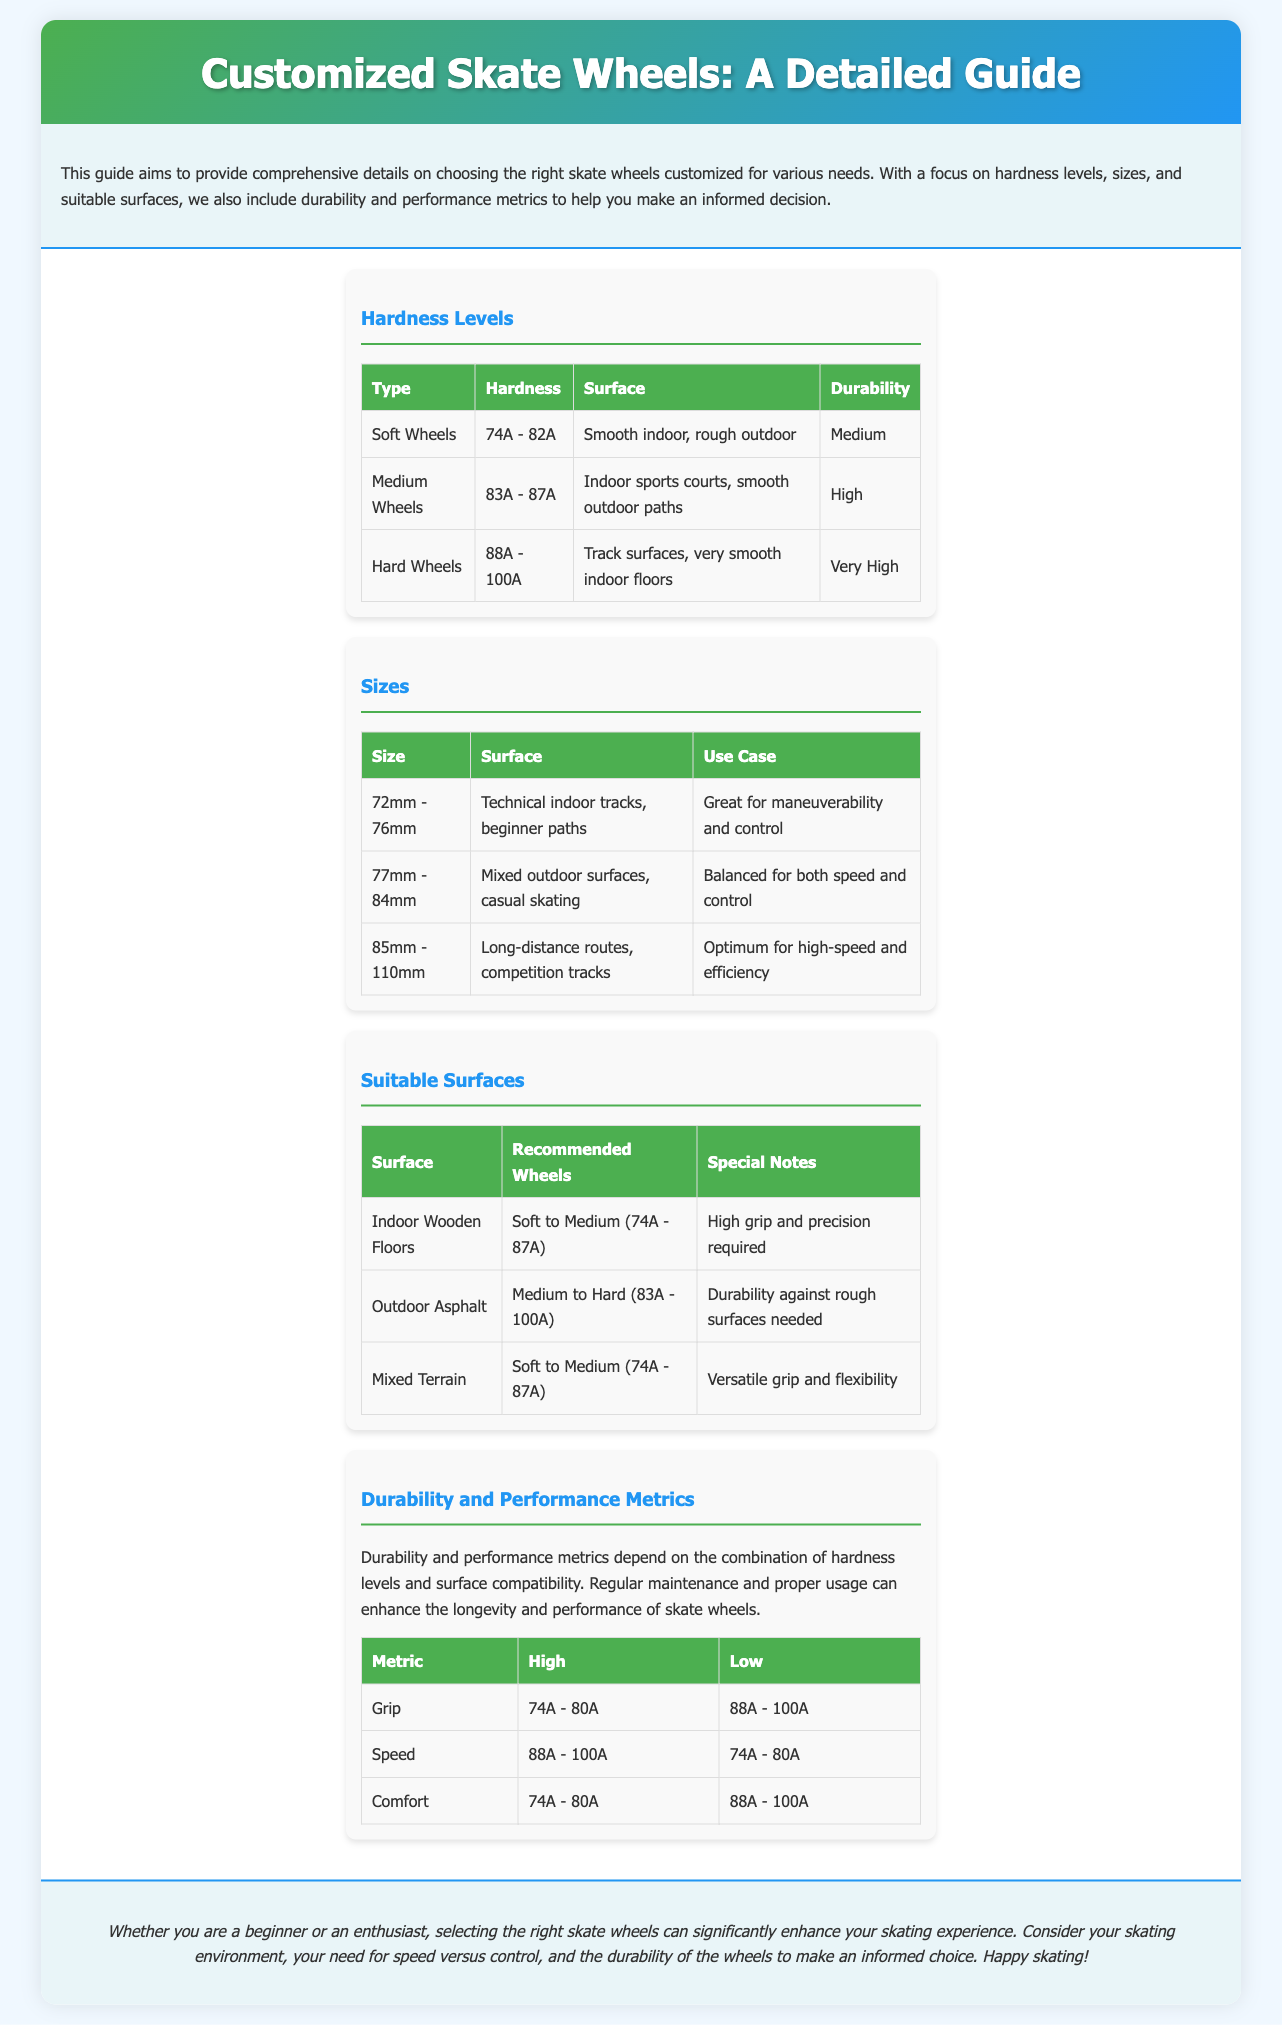what is the hardness range for soft wheels? The document states that the hardness for soft wheels ranges from 74A to 82A.
Answer: 74A - 82A what surfaces are medium wheels suitable for? According to the document, medium wheels are suitable for indoor sports courts and smooth outdoor paths.
Answer: Indoor sports courts, smooth outdoor paths what is the size range for high-speed wheels? The document indicates that the size range for high-speed wheels is 85mm to 110mm.
Answer: 85mm - 110mm which wheels are recommended for indoor wooden floors? The document recommends soft to medium wheels for indoor wooden floors.
Answer: Soft to Medium (74A - 87A) what is the grip metric range for high performance? The document mentions that the grip metric for high performance is 74A - 80A.
Answer: 74A - 80A why might an amateur skater choose soft wheels? Soft wheels provide better grip and comfort, making them suitable for beginners.
Answer: Better grip and comfort what special notes are provided for outdoor asphalt surfaces? The document notes that durability against rough surfaces is needed for outdoor asphalt.
Answer: Durability against rough surfaces needed what type of wheels should be used on mixed terrain? The document suggests using soft to medium wheels on mixed terrain.
Answer: Soft to Medium (74A - 87A) which hardness range is ideal for speed? The document highlights that a hardness range of 88A - 100A is ideal for speed.
Answer: 88A - 100A 